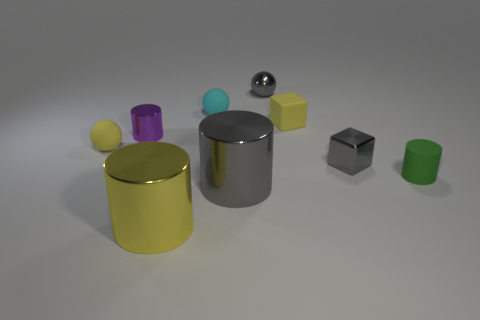Subtract all metallic balls. How many balls are left? 2 Add 1 yellow shiny cylinders. How many objects exist? 10 Subtract all yellow blocks. How many blocks are left? 1 Subtract all yellow rubber things. Subtract all big yellow shiny cylinders. How many objects are left? 6 Add 9 small purple shiny cylinders. How many small purple shiny cylinders are left? 10 Add 4 large blue spheres. How many large blue spheres exist? 4 Subtract 0 purple cubes. How many objects are left? 9 Subtract all balls. How many objects are left? 6 Subtract 1 cubes. How many cubes are left? 1 Subtract all green blocks. Subtract all red cylinders. How many blocks are left? 2 